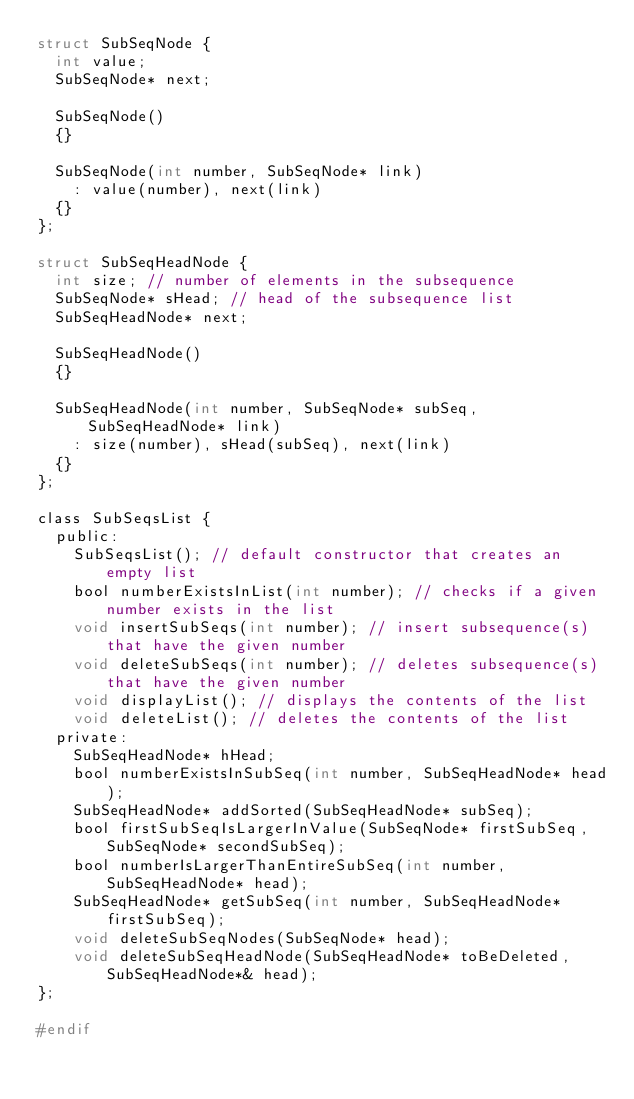<code> <loc_0><loc_0><loc_500><loc_500><_C_>struct SubSeqNode {
	int value;
	SubSeqNode* next;

	SubSeqNode()
	{}

	SubSeqNode(int number, SubSeqNode* link)
		: value(number), next(link)
	{}
};

struct SubSeqHeadNode {
	int size; // number of elements in the subsequence
	SubSeqNode* sHead; // head of the subsequence list
	SubSeqHeadNode* next;

	SubSeqHeadNode()
	{}

	SubSeqHeadNode(int number, SubSeqNode* subSeq, SubSeqHeadNode* link)
		: size(number), sHead(subSeq), next(link)
	{}
};

class SubSeqsList {
	public:
		SubSeqsList(); // default constructor that creates an empty list
		bool numberExistsInList(int number); // checks if a given number exists in the list
		void insertSubSeqs(int number); // insert subsequence(s) that have the given number
		void deleteSubSeqs(int number); // deletes subsequence(s) that have the given number
		void displayList(); // displays the contents of the list
		void deleteList(); // deletes the contents of the list
	private:
		SubSeqHeadNode* hHead;
		bool numberExistsInSubSeq(int number, SubSeqHeadNode* head);
		SubSeqHeadNode* addSorted(SubSeqHeadNode* subSeq);
		bool firstSubSeqIsLargerInValue(SubSeqNode* firstSubSeq, SubSeqNode* secondSubSeq);
		bool numberIsLargerThanEntireSubSeq(int number, SubSeqHeadNode* head);
		SubSeqHeadNode* getSubSeq(int number, SubSeqHeadNode* firstSubSeq);
		void deleteSubSeqNodes(SubSeqNode* head);
		void deleteSubSeqHeadNode(SubSeqHeadNode* toBeDeleted, SubSeqHeadNode*& head);
};

#endif</code> 